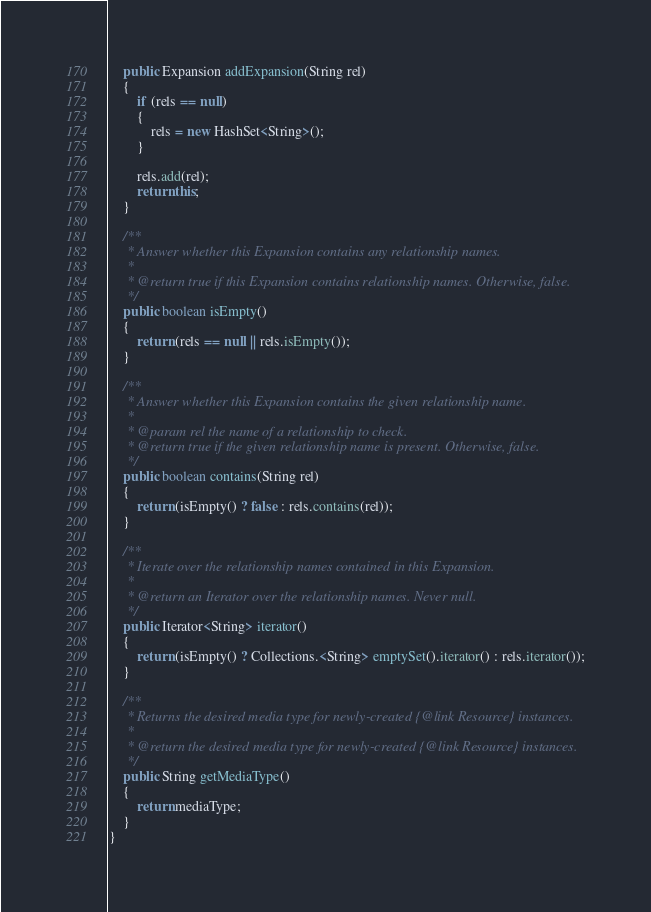Convert code to text. <code><loc_0><loc_0><loc_500><loc_500><_Java_>	public Expansion addExpansion(String rel)
	{
		if (rels == null)
		{
			rels = new HashSet<String>();
		}

		rels.add(rel);
		return this;
	}

	/**
	 * Answer whether this Expansion contains any relationship names.
	 * 
	 * @return true if this Expansion contains relationship names. Otherwise, false.
	 */
	public boolean isEmpty()
	{
		return (rels == null || rels.isEmpty());
	}

	/**
	 * Answer whether this Expansion contains the given relationship name.
	 * 
	 * @param rel the name of a relationship to check.
	 * @return true if the given relationship name is present. Otherwise, false.
	 */
	public boolean contains(String rel)
	{
		return (isEmpty() ? false : rels.contains(rel));
	}

	/**
	 * Iterate over the relationship names contained in this Expansion.
	 * 
	 * @return an Iterator over the relationship names. Never null.
	 */
	public Iterator<String> iterator()
	{
		return (isEmpty() ? Collections.<String> emptySet().iterator() : rels.iterator());
	}

	/**
	 * Returns the desired media type for newly-created {@link Resource} instances.
	 * 
	 * @return the desired media type for newly-created {@link Resource} instances.
	 */
	public String getMediaType()
	{
		return mediaType;
	}
}
</code> 